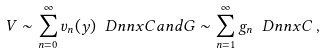Convert formula to latex. <formula><loc_0><loc_0><loc_500><loc_500>V \sim \sum _ { n = 0 } ^ { \infty } v _ { n } ( y ) \ D n n x { C } a n d G \sim \sum _ { n = 1 } ^ { \infty } g _ { n } \ D n n x { C } \, ,</formula> 